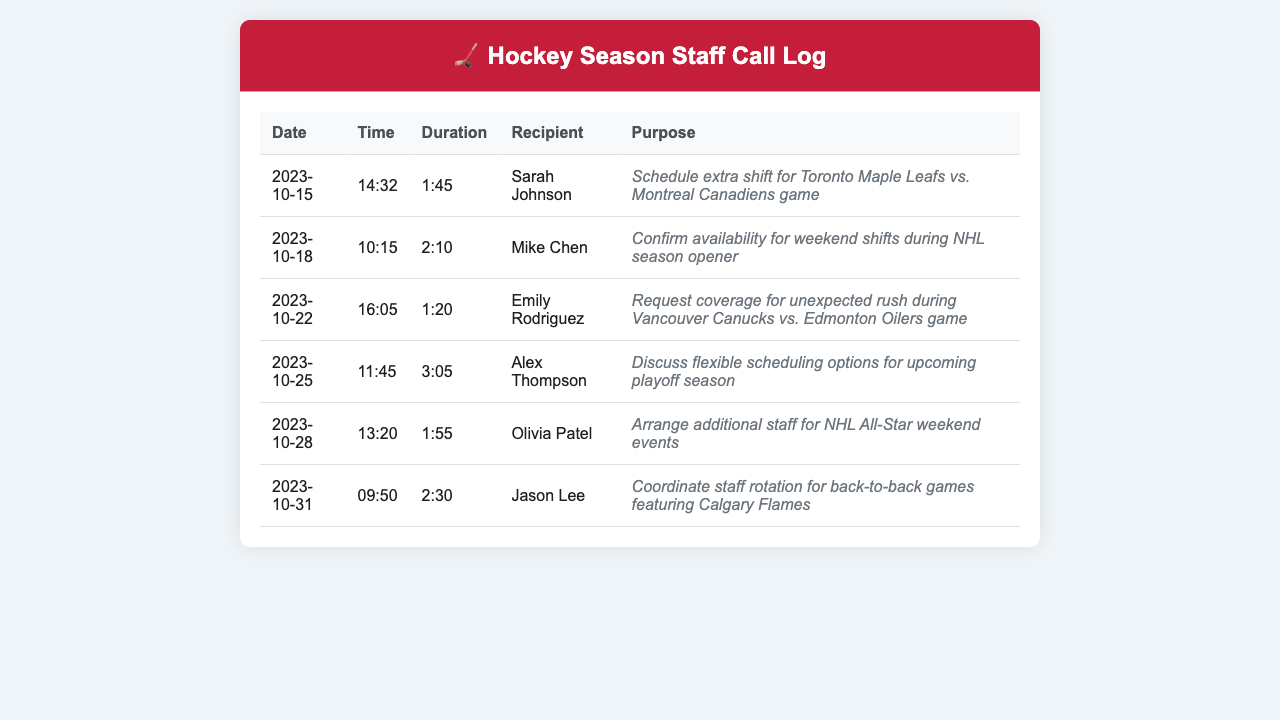What is the date of the call to Sarah Johnson? The date of the call to Sarah Johnson is found in the first row of the table under the 'Date' column.
Answer: 2023-10-15 Who was contacted on October 18? The table indicates that Mike Chen was the recipient of the call made on October 18.
Answer: Mike Chen What is the duration of the call made on October 25? The duration of the call is listed in the table under the 'Duration' column for the call on October 25.
Answer: 3:05 How many calls are listed in the document? The total number of calls can be determined by counting the entries in the table.
Answer: 6 What was the purpose of the call to Jason Lee? The purpose of the call to Jason Lee is detailed in the 'Purpose' column for the specific date in the table.
Answer: Coordinate staff rotation for back-to-back games featuring Calgary Flames Which staff member was contacted to schedule an extra shift for a hockey game? The call to schedule an extra shift for the hockey game involved Sarah Johnson, as per the purpose listed in the document.
Answer: Sarah Johnson Which game was referenced in the call to Emily Rodriguez? The call to Emily Rodriguez is mentioned in context with the Vancouver Canucks vs. Edmonton Oilers.
Answer: Vancouver Canucks vs. Edmonton Oilers What time was the call to Olivia Patel answered? The time of the call to Olivia Patel is recorded in the table under the 'Time' column.
Answer: 13:20 What is the purpose of the call made on October 22? The purpose of the call made on October 22 is specified in the document under the 'Purpose' column for that date.
Answer: Request coverage for unexpected rush during Vancouver Canucks vs. Edmonton Oilers game 